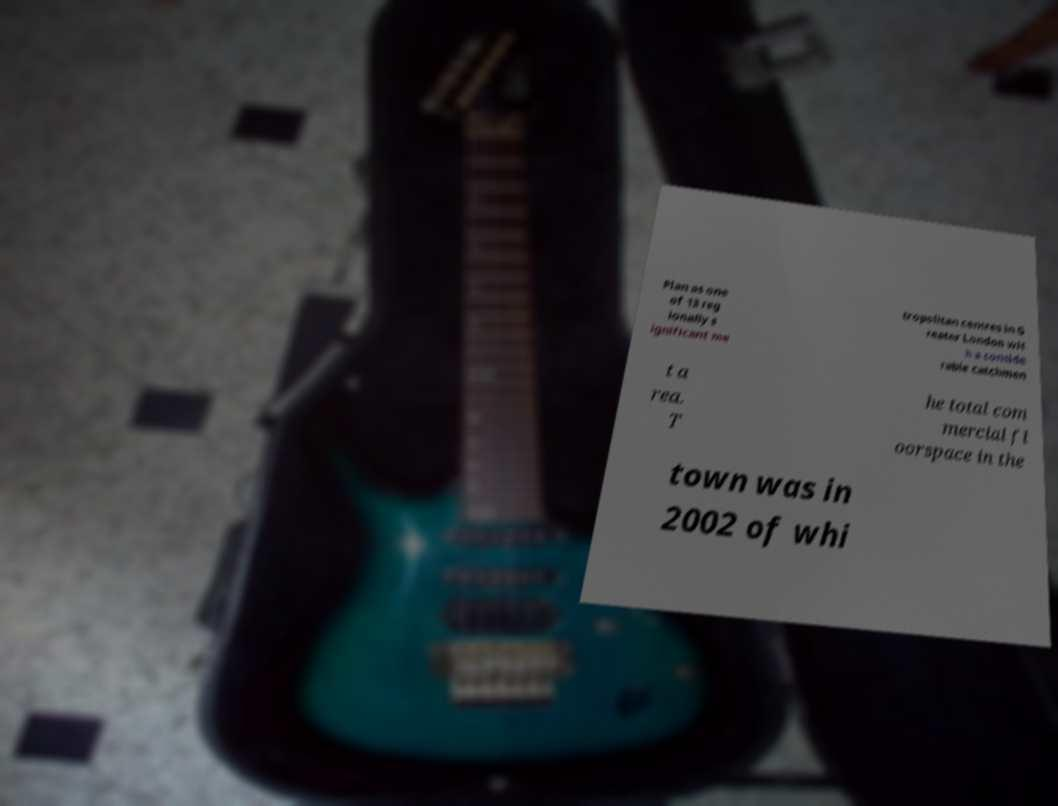Could you extract and type out the text from this image? Plan as one of 13 reg ionally s ignificant me tropolitan centres in G reater London wit h a conside rable catchmen t a rea. T he total com mercial fl oorspace in the town was in 2002 of whi 